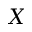Convert formula to latex. <formula><loc_0><loc_0><loc_500><loc_500>X</formula> 